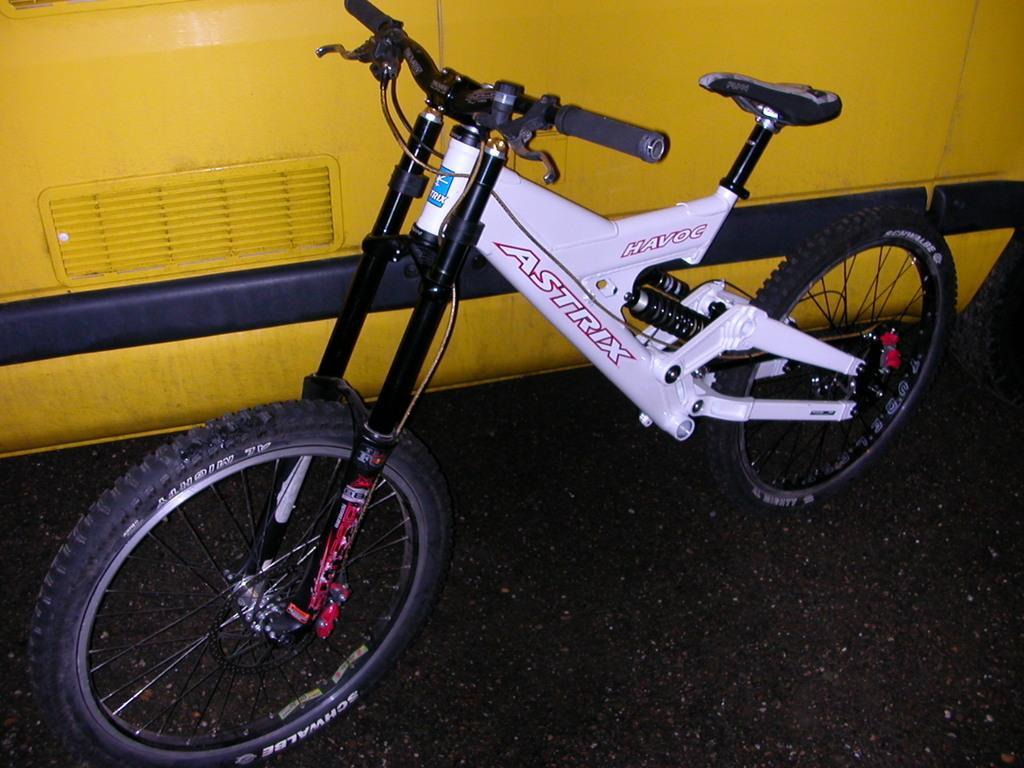Could you give a brief overview of what you see in this image? In this image I can see black colored ground and on it I can see a bicycle which is black and white in color and a vehicle which is yellow and black in color. 